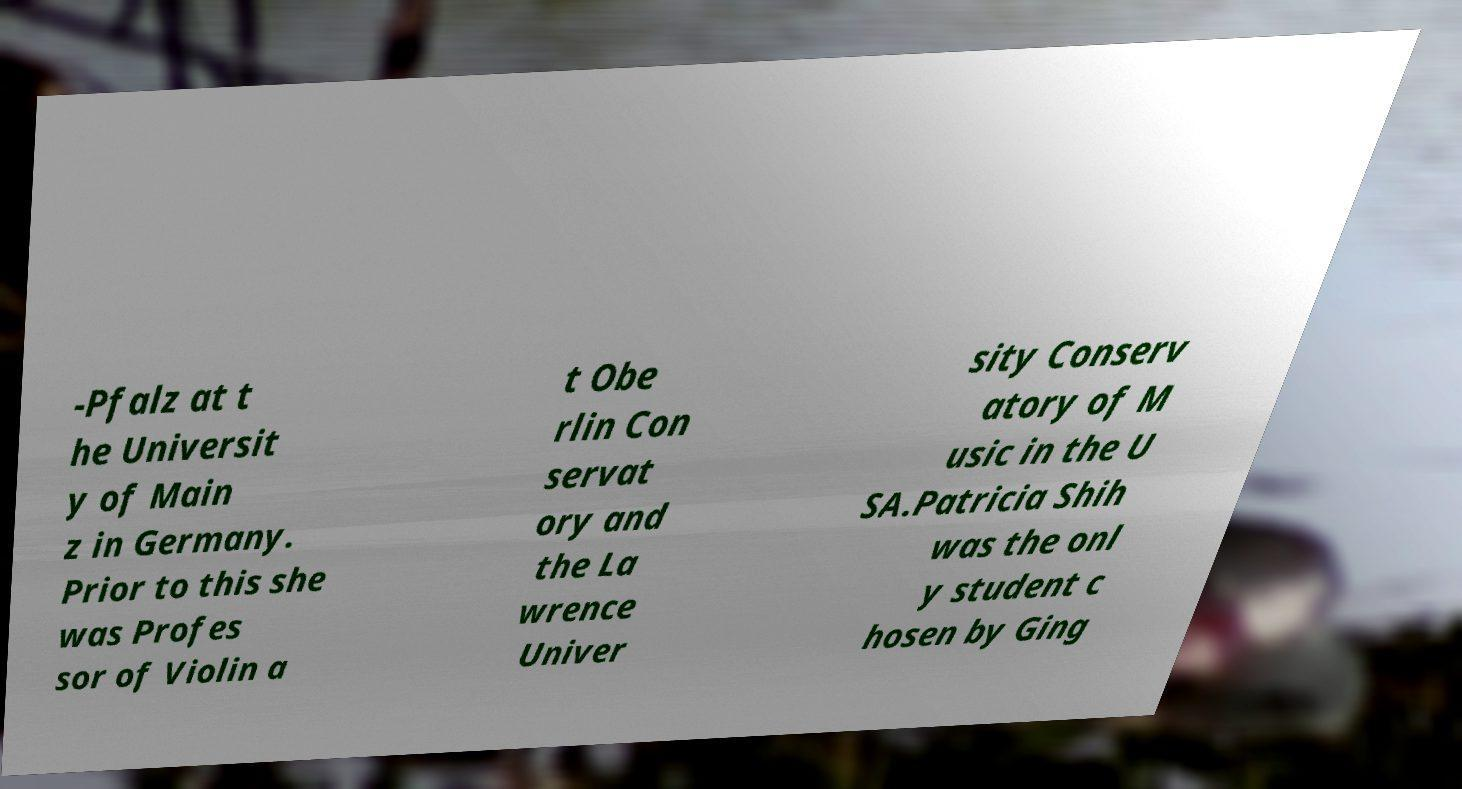Could you assist in decoding the text presented in this image and type it out clearly? -Pfalz at t he Universit y of Main z in Germany. Prior to this she was Profes sor of Violin a t Obe rlin Con servat ory and the La wrence Univer sity Conserv atory of M usic in the U SA.Patricia Shih was the onl y student c hosen by Ging 